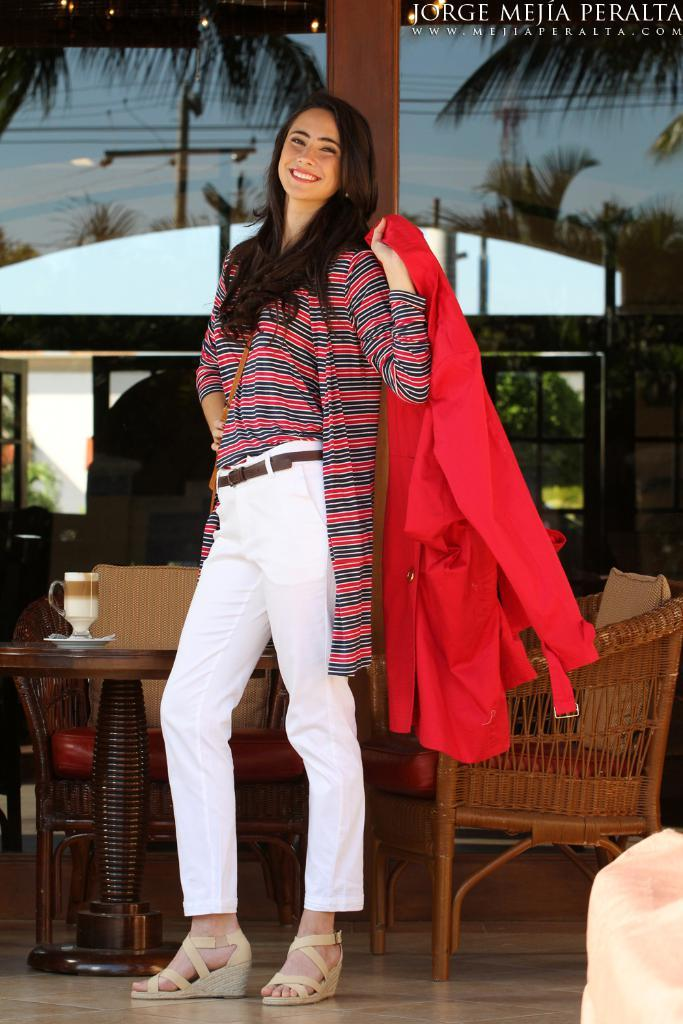What is the main subject of the image? There is a beautiful woman in the image. What is the woman doing in the image? The woman is standing. What is the woman holding in the image? The woman is holding a red color dress. What can be seen in the background of the image? There are chairs, trees, and the sky visible in the background of the image. What type of mitten is the woman wearing in the image? There is no mitten present in the image; the woman is holding a red color dress. 